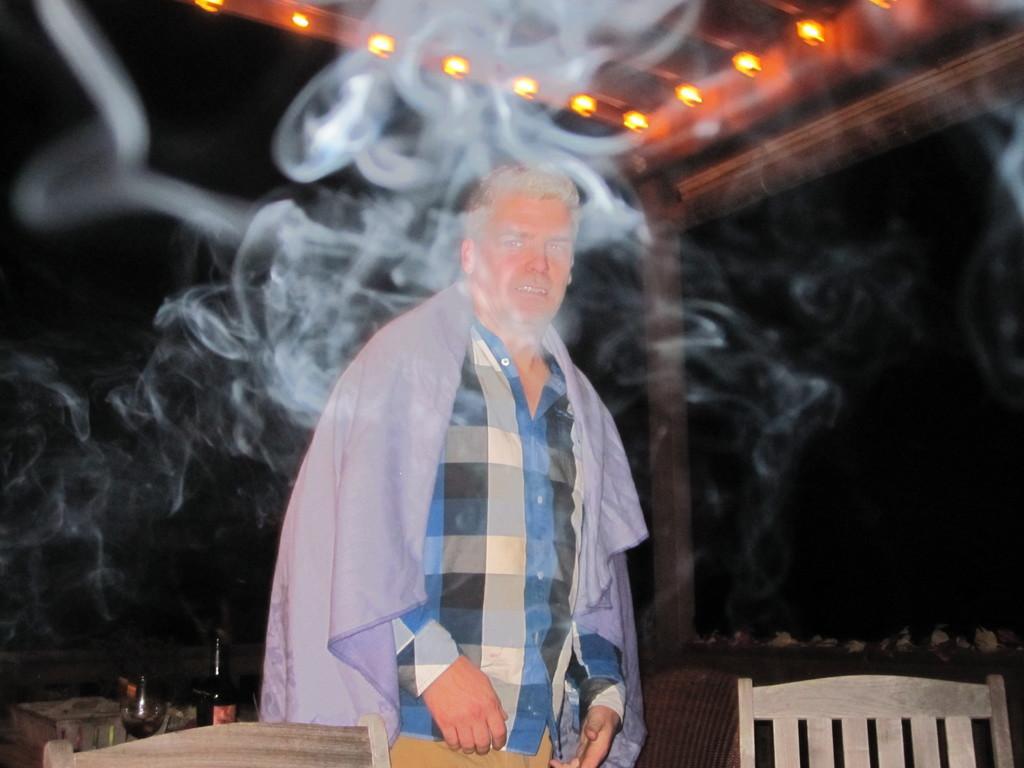Please provide a concise description of this image. This image consists of a man. He is wearing a blue shirt and a cloth. In the front, we can see the smoke. In the background, there is a pillar. At the top, there are many lamps fixed to the roof. On the right, there is a chair. 